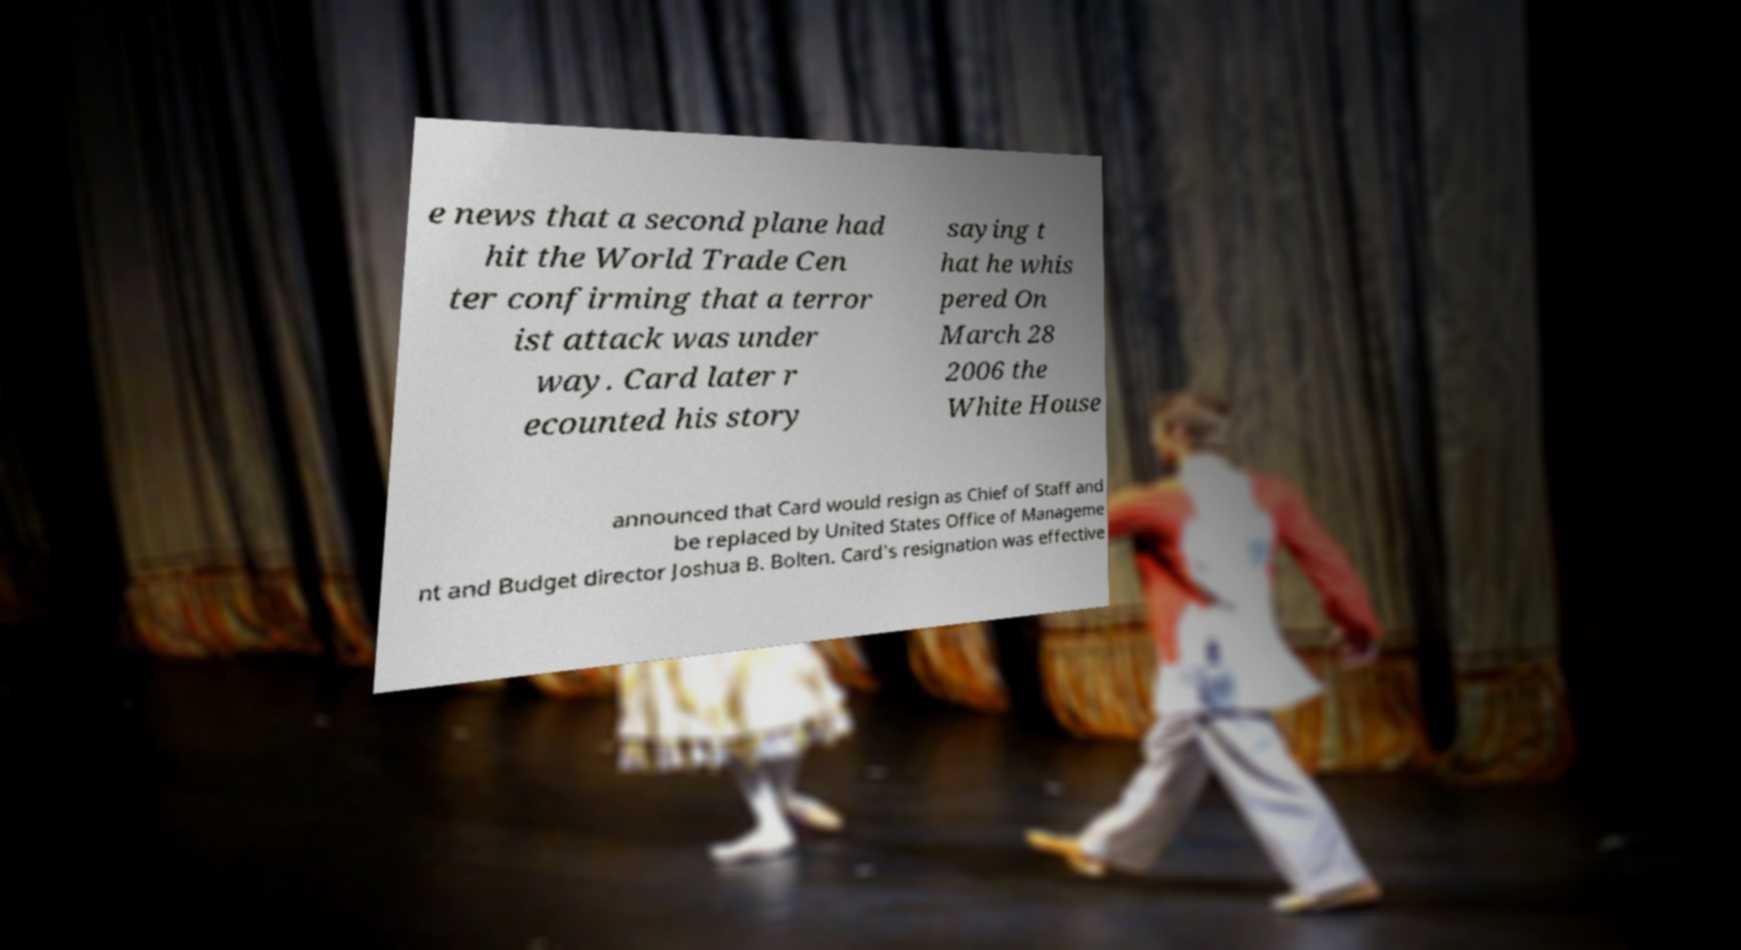Could you extract and type out the text from this image? e news that a second plane had hit the World Trade Cen ter confirming that a terror ist attack was under way. Card later r ecounted his story saying t hat he whis pered On March 28 2006 the White House announced that Card would resign as Chief of Staff and be replaced by United States Office of Manageme nt and Budget director Joshua B. Bolten. Card's resignation was effective 